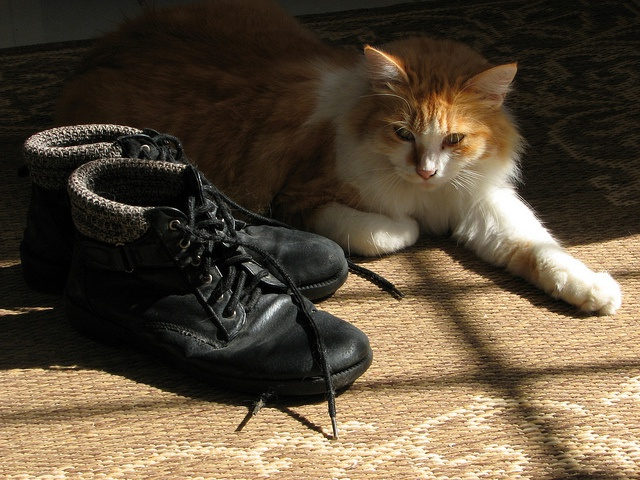Describe the objects in this image and their specific colors. I can see a cat in black, gray, maroon, and ivory tones in this image. 